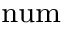<formula> <loc_0><loc_0><loc_500><loc_500>\Pi ^ { n u m }</formula> 